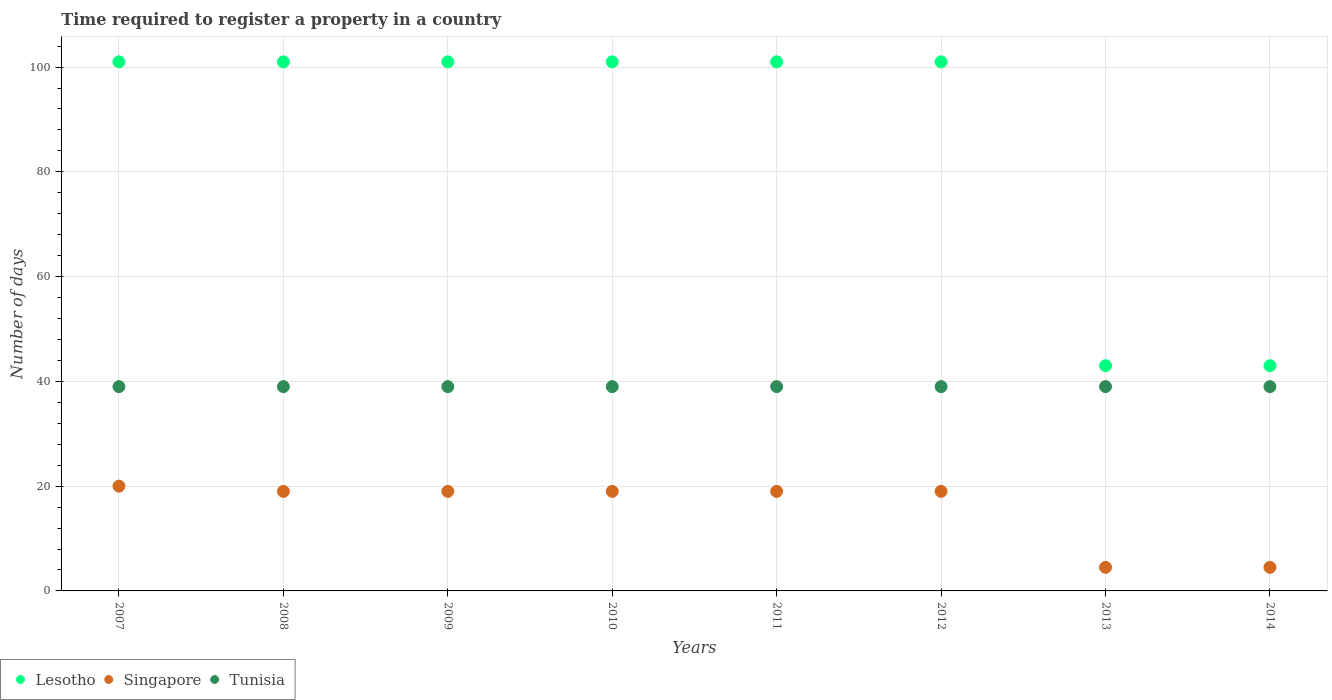Is the number of dotlines equal to the number of legend labels?
Provide a short and direct response. Yes. What is the number of days required to register a property in Tunisia in 2007?
Provide a succinct answer. 39. Across all years, what is the maximum number of days required to register a property in Tunisia?
Your answer should be very brief. 39. Across all years, what is the minimum number of days required to register a property in Lesotho?
Offer a very short reply. 43. What is the total number of days required to register a property in Lesotho in the graph?
Keep it short and to the point. 692. What is the average number of days required to register a property in Lesotho per year?
Provide a short and direct response. 86.5. In the year 2014, what is the difference between the number of days required to register a property in Lesotho and number of days required to register a property in Singapore?
Offer a very short reply. 38.5. What is the ratio of the number of days required to register a property in Singapore in 2011 to that in 2013?
Your answer should be compact. 4.22. Is the difference between the number of days required to register a property in Lesotho in 2010 and 2012 greater than the difference between the number of days required to register a property in Singapore in 2010 and 2012?
Offer a very short reply. No. What is the difference between the highest and the second highest number of days required to register a property in Tunisia?
Keep it short and to the point. 0. What is the difference between the highest and the lowest number of days required to register a property in Lesotho?
Provide a short and direct response. 58. Is the sum of the number of days required to register a property in Tunisia in 2007 and 2014 greater than the maximum number of days required to register a property in Singapore across all years?
Your response must be concise. Yes. Is it the case that in every year, the sum of the number of days required to register a property in Singapore and number of days required to register a property in Tunisia  is greater than the number of days required to register a property in Lesotho?
Your answer should be very brief. No. Does the number of days required to register a property in Lesotho monotonically increase over the years?
Offer a very short reply. No. Is the number of days required to register a property in Singapore strictly greater than the number of days required to register a property in Lesotho over the years?
Your answer should be very brief. No. Is the number of days required to register a property in Tunisia strictly less than the number of days required to register a property in Singapore over the years?
Ensure brevity in your answer.  No. Does the graph contain grids?
Provide a short and direct response. Yes. How many legend labels are there?
Your answer should be compact. 3. How are the legend labels stacked?
Offer a terse response. Horizontal. What is the title of the graph?
Give a very brief answer. Time required to register a property in a country. What is the label or title of the Y-axis?
Offer a very short reply. Number of days. What is the Number of days of Lesotho in 2007?
Keep it short and to the point. 101. What is the Number of days in Tunisia in 2007?
Provide a succinct answer. 39. What is the Number of days in Lesotho in 2008?
Offer a terse response. 101. What is the Number of days of Singapore in 2008?
Your answer should be very brief. 19. What is the Number of days in Tunisia in 2008?
Keep it short and to the point. 39. What is the Number of days of Lesotho in 2009?
Your answer should be compact. 101. What is the Number of days of Singapore in 2009?
Keep it short and to the point. 19. What is the Number of days of Lesotho in 2010?
Offer a very short reply. 101. What is the Number of days in Singapore in 2010?
Give a very brief answer. 19. What is the Number of days of Tunisia in 2010?
Ensure brevity in your answer.  39. What is the Number of days in Lesotho in 2011?
Provide a succinct answer. 101. What is the Number of days of Singapore in 2011?
Provide a short and direct response. 19. What is the Number of days of Lesotho in 2012?
Offer a terse response. 101. What is the Number of days of Singapore in 2012?
Your answer should be compact. 19. What is the Number of days of Tunisia in 2012?
Your answer should be compact. 39. What is the Number of days in Lesotho in 2013?
Provide a succinct answer. 43. What is the Number of days in Singapore in 2013?
Your response must be concise. 4.5. What is the Number of days in Singapore in 2014?
Offer a terse response. 4.5. What is the Number of days of Tunisia in 2014?
Keep it short and to the point. 39. Across all years, what is the maximum Number of days in Lesotho?
Your response must be concise. 101. Across all years, what is the maximum Number of days of Tunisia?
Your answer should be compact. 39. Across all years, what is the minimum Number of days of Singapore?
Provide a short and direct response. 4.5. What is the total Number of days of Lesotho in the graph?
Provide a short and direct response. 692. What is the total Number of days in Singapore in the graph?
Your answer should be compact. 124. What is the total Number of days in Tunisia in the graph?
Ensure brevity in your answer.  312. What is the difference between the Number of days in Singapore in 2007 and that in 2008?
Your answer should be very brief. 1. What is the difference between the Number of days of Tunisia in 2007 and that in 2008?
Offer a terse response. 0. What is the difference between the Number of days of Singapore in 2007 and that in 2009?
Provide a succinct answer. 1. What is the difference between the Number of days in Tunisia in 2007 and that in 2009?
Keep it short and to the point. 0. What is the difference between the Number of days of Lesotho in 2007 and that in 2010?
Ensure brevity in your answer.  0. What is the difference between the Number of days of Tunisia in 2007 and that in 2010?
Provide a succinct answer. 0. What is the difference between the Number of days in Lesotho in 2007 and that in 2011?
Make the answer very short. 0. What is the difference between the Number of days of Lesotho in 2007 and that in 2012?
Provide a succinct answer. 0. What is the difference between the Number of days in Tunisia in 2007 and that in 2012?
Provide a short and direct response. 0. What is the difference between the Number of days in Singapore in 2007 and that in 2013?
Give a very brief answer. 15.5. What is the difference between the Number of days of Tunisia in 2007 and that in 2013?
Give a very brief answer. 0. What is the difference between the Number of days of Lesotho in 2007 and that in 2014?
Make the answer very short. 58. What is the difference between the Number of days in Tunisia in 2007 and that in 2014?
Give a very brief answer. 0. What is the difference between the Number of days of Lesotho in 2008 and that in 2009?
Your response must be concise. 0. What is the difference between the Number of days in Singapore in 2008 and that in 2009?
Keep it short and to the point. 0. What is the difference between the Number of days in Singapore in 2008 and that in 2011?
Offer a terse response. 0. What is the difference between the Number of days in Tunisia in 2008 and that in 2011?
Offer a very short reply. 0. What is the difference between the Number of days in Lesotho in 2008 and that in 2012?
Provide a short and direct response. 0. What is the difference between the Number of days in Singapore in 2008 and that in 2012?
Give a very brief answer. 0. What is the difference between the Number of days in Tunisia in 2008 and that in 2012?
Make the answer very short. 0. What is the difference between the Number of days of Lesotho in 2008 and that in 2013?
Offer a terse response. 58. What is the difference between the Number of days of Singapore in 2008 and that in 2013?
Provide a succinct answer. 14.5. What is the difference between the Number of days of Tunisia in 2008 and that in 2013?
Your answer should be compact. 0. What is the difference between the Number of days in Tunisia in 2008 and that in 2014?
Offer a terse response. 0. What is the difference between the Number of days in Lesotho in 2009 and that in 2010?
Ensure brevity in your answer.  0. What is the difference between the Number of days in Lesotho in 2009 and that in 2011?
Ensure brevity in your answer.  0. What is the difference between the Number of days in Singapore in 2009 and that in 2011?
Ensure brevity in your answer.  0. What is the difference between the Number of days of Lesotho in 2009 and that in 2012?
Keep it short and to the point. 0. What is the difference between the Number of days of Tunisia in 2009 and that in 2013?
Ensure brevity in your answer.  0. What is the difference between the Number of days of Singapore in 2009 and that in 2014?
Make the answer very short. 14.5. What is the difference between the Number of days of Tunisia in 2010 and that in 2011?
Your answer should be compact. 0. What is the difference between the Number of days of Lesotho in 2010 and that in 2013?
Offer a terse response. 58. What is the difference between the Number of days in Lesotho in 2010 and that in 2014?
Your answer should be very brief. 58. What is the difference between the Number of days in Singapore in 2010 and that in 2014?
Provide a succinct answer. 14.5. What is the difference between the Number of days in Tunisia in 2011 and that in 2012?
Your answer should be compact. 0. What is the difference between the Number of days in Tunisia in 2011 and that in 2013?
Offer a very short reply. 0. What is the difference between the Number of days in Tunisia in 2011 and that in 2014?
Make the answer very short. 0. What is the difference between the Number of days of Singapore in 2012 and that in 2013?
Ensure brevity in your answer.  14.5. What is the difference between the Number of days in Lesotho in 2012 and that in 2014?
Provide a succinct answer. 58. What is the difference between the Number of days of Lesotho in 2013 and that in 2014?
Make the answer very short. 0. What is the difference between the Number of days in Singapore in 2013 and that in 2014?
Make the answer very short. 0. What is the difference between the Number of days of Tunisia in 2013 and that in 2014?
Ensure brevity in your answer.  0. What is the difference between the Number of days in Lesotho in 2007 and the Number of days in Tunisia in 2008?
Provide a succinct answer. 62. What is the difference between the Number of days of Singapore in 2007 and the Number of days of Tunisia in 2008?
Offer a terse response. -19. What is the difference between the Number of days of Singapore in 2007 and the Number of days of Tunisia in 2009?
Your answer should be very brief. -19. What is the difference between the Number of days in Lesotho in 2007 and the Number of days in Singapore in 2010?
Ensure brevity in your answer.  82. What is the difference between the Number of days in Lesotho in 2007 and the Number of days in Tunisia in 2010?
Offer a very short reply. 62. What is the difference between the Number of days of Lesotho in 2007 and the Number of days of Singapore in 2011?
Provide a short and direct response. 82. What is the difference between the Number of days in Lesotho in 2007 and the Number of days in Singapore in 2012?
Your answer should be compact. 82. What is the difference between the Number of days in Lesotho in 2007 and the Number of days in Singapore in 2013?
Make the answer very short. 96.5. What is the difference between the Number of days in Singapore in 2007 and the Number of days in Tunisia in 2013?
Ensure brevity in your answer.  -19. What is the difference between the Number of days in Lesotho in 2007 and the Number of days in Singapore in 2014?
Your response must be concise. 96.5. What is the difference between the Number of days in Singapore in 2007 and the Number of days in Tunisia in 2014?
Offer a very short reply. -19. What is the difference between the Number of days of Singapore in 2008 and the Number of days of Tunisia in 2009?
Offer a terse response. -20. What is the difference between the Number of days in Lesotho in 2008 and the Number of days in Singapore in 2010?
Ensure brevity in your answer.  82. What is the difference between the Number of days in Singapore in 2008 and the Number of days in Tunisia in 2010?
Make the answer very short. -20. What is the difference between the Number of days in Lesotho in 2008 and the Number of days in Singapore in 2011?
Your answer should be compact. 82. What is the difference between the Number of days of Lesotho in 2008 and the Number of days of Tunisia in 2012?
Provide a short and direct response. 62. What is the difference between the Number of days in Lesotho in 2008 and the Number of days in Singapore in 2013?
Your answer should be very brief. 96.5. What is the difference between the Number of days in Lesotho in 2008 and the Number of days in Tunisia in 2013?
Ensure brevity in your answer.  62. What is the difference between the Number of days of Singapore in 2008 and the Number of days of Tunisia in 2013?
Your answer should be very brief. -20. What is the difference between the Number of days of Lesotho in 2008 and the Number of days of Singapore in 2014?
Give a very brief answer. 96.5. What is the difference between the Number of days of Singapore in 2008 and the Number of days of Tunisia in 2014?
Provide a short and direct response. -20. What is the difference between the Number of days of Lesotho in 2009 and the Number of days of Singapore in 2010?
Offer a terse response. 82. What is the difference between the Number of days of Lesotho in 2009 and the Number of days of Tunisia in 2010?
Your answer should be compact. 62. What is the difference between the Number of days in Singapore in 2009 and the Number of days in Tunisia in 2010?
Your response must be concise. -20. What is the difference between the Number of days in Lesotho in 2009 and the Number of days in Singapore in 2011?
Your answer should be compact. 82. What is the difference between the Number of days of Lesotho in 2009 and the Number of days of Singapore in 2012?
Provide a succinct answer. 82. What is the difference between the Number of days of Lesotho in 2009 and the Number of days of Tunisia in 2012?
Your answer should be very brief. 62. What is the difference between the Number of days of Lesotho in 2009 and the Number of days of Singapore in 2013?
Provide a short and direct response. 96.5. What is the difference between the Number of days of Lesotho in 2009 and the Number of days of Singapore in 2014?
Give a very brief answer. 96.5. What is the difference between the Number of days in Singapore in 2009 and the Number of days in Tunisia in 2014?
Keep it short and to the point. -20. What is the difference between the Number of days in Lesotho in 2010 and the Number of days in Singapore in 2011?
Your answer should be compact. 82. What is the difference between the Number of days in Singapore in 2010 and the Number of days in Tunisia in 2011?
Your answer should be compact. -20. What is the difference between the Number of days in Lesotho in 2010 and the Number of days in Singapore in 2012?
Provide a succinct answer. 82. What is the difference between the Number of days in Singapore in 2010 and the Number of days in Tunisia in 2012?
Your response must be concise. -20. What is the difference between the Number of days of Lesotho in 2010 and the Number of days of Singapore in 2013?
Your answer should be very brief. 96.5. What is the difference between the Number of days of Lesotho in 2010 and the Number of days of Tunisia in 2013?
Provide a succinct answer. 62. What is the difference between the Number of days in Singapore in 2010 and the Number of days in Tunisia in 2013?
Your response must be concise. -20. What is the difference between the Number of days in Lesotho in 2010 and the Number of days in Singapore in 2014?
Your answer should be compact. 96.5. What is the difference between the Number of days in Lesotho in 2010 and the Number of days in Tunisia in 2014?
Your response must be concise. 62. What is the difference between the Number of days in Lesotho in 2011 and the Number of days in Singapore in 2012?
Ensure brevity in your answer.  82. What is the difference between the Number of days in Lesotho in 2011 and the Number of days in Singapore in 2013?
Ensure brevity in your answer.  96.5. What is the difference between the Number of days of Lesotho in 2011 and the Number of days of Tunisia in 2013?
Make the answer very short. 62. What is the difference between the Number of days in Lesotho in 2011 and the Number of days in Singapore in 2014?
Your answer should be very brief. 96.5. What is the difference between the Number of days in Lesotho in 2011 and the Number of days in Tunisia in 2014?
Keep it short and to the point. 62. What is the difference between the Number of days in Singapore in 2011 and the Number of days in Tunisia in 2014?
Offer a terse response. -20. What is the difference between the Number of days of Lesotho in 2012 and the Number of days of Singapore in 2013?
Give a very brief answer. 96.5. What is the difference between the Number of days of Lesotho in 2012 and the Number of days of Singapore in 2014?
Make the answer very short. 96.5. What is the difference between the Number of days in Lesotho in 2012 and the Number of days in Tunisia in 2014?
Offer a terse response. 62. What is the difference between the Number of days in Lesotho in 2013 and the Number of days in Singapore in 2014?
Your answer should be very brief. 38.5. What is the difference between the Number of days in Lesotho in 2013 and the Number of days in Tunisia in 2014?
Ensure brevity in your answer.  4. What is the difference between the Number of days of Singapore in 2013 and the Number of days of Tunisia in 2014?
Keep it short and to the point. -34.5. What is the average Number of days of Lesotho per year?
Offer a very short reply. 86.5. What is the average Number of days of Tunisia per year?
Offer a very short reply. 39. In the year 2007, what is the difference between the Number of days of Lesotho and Number of days of Singapore?
Your answer should be very brief. 81. In the year 2008, what is the difference between the Number of days of Singapore and Number of days of Tunisia?
Offer a terse response. -20. In the year 2010, what is the difference between the Number of days of Lesotho and Number of days of Singapore?
Provide a short and direct response. 82. In the year 2010, what is the difference between the Number of days of Lesotho and Number of days of Tunisia?
Offer a very short reply. 62. In the year 2010, what is the difference between the Number of days in Singapore and Number of days in Tunisia?
Provide a succinct answer. -20. In the year 2011, what is the difference between the Number of days in Lesotho and Number of days in Tunisia?
Give a very brief answer. 62. In the year 2012, what is the difference between the Number of days of Lesotho and Number of days of Singapore?
Make the answer very short. 82. In the year 2012, what is the difference between the Number of days of Lesotho and Number of days of Tunisia?
Your answer should be compact. 62. In the year 2013, what is the difference between the Number of days in Lesotho and Number of days in Singapore?
Offer a very short reply. 38.5. In the year 2013, what is the difference between the Number of days of Singapore and Number of days of Tunisia?
Provide a succinct answer. -34.5. In the year 2014, what is the difference between the Number of days of Lesotho and Number of days of Singapore?
Give a very brief answer. 38.5. In the year 2014, what is the difference between the Number of days of Singapore and Number of days of Tunisia?
Your answer should be very brief. -34.5. What is the ratio of the Number of days of Singapore in 2007 to that in 2008?
Your answer should be compact. 1.05. What is the ratio of the Number of days in Singapore in 2007 to that in 2009?
Your answer should be very brief. 1.05. What is the ratio of the Number of days in Singapore in 2007 to that in 2010?
Your response must be concise. 1.05. What is the ratio of the Number of days of Singapore in 2007 to that in 2011?
Offer a very short reply. 1.05. What is the ratio of the Number of days in Singapore in 2007 to that in 2012?
Your response must be concise. 1.05. What is the ratio of the Number of days of Lesotho in 2007 to that in 2013?
Ensure brevity in your answer.  2.35. What is the ratio of the Number of days in Singapore in 2007 to that in 2013?
Give a very brief answer. 4.44. What is the ratio of the Number of days of Tunisia in 2007 to that in 2013?
Ensure brevity in your answer.  1. What is the ratio of the Number of days in Lesotho in 2007 to that in 2014?
Ensure brevity in your answer.  2.35. What is the ratio of the Number of days in Singapore in 2007 to that in 2014?
Make the answer very short. 4.44. What is the ratio of the Number of days in Lesotho in 2008 to that in 2010?
Make the answer very short. 1. What is the ratio of the Number of days of Tunisia in 2008 to that in 2010?
Offer a very short reply. 1. What is the ratio of the Number of days of Singapore in 2008 to that in 2012?
Give a very brief answer. 1. What is the ratio of the Number of days in Lesotho in 2008 to that in 2013?
Give a very brief answer. 2.35. What is the ratio of the Number of days in Singapore in 2008 to that in 2013?
Ensure brevity in your answer.  4.22. What is the ratio of the Number of days of Lesotho in 2008 to that in 2014?
Give a very brief answer. 2.35. What is the ratio of the Number of days of Singapore in 2008 to that in 2014?
Your response must be concise. 4.22. What is the ratio of the Number of days of Tunisia in 2008 to that in 2014?
Offer a terse response. 1. What is the ratio of the Number of days of Lesotho in 2009 to that in 2010?
Give a very brief answer. 1. What is the ratio of the Number of days in Singapore in 2009 to that in 2010?
Keep it short and to the point. 1. What is the ratio of the Number of days in Tunisia in 2009 to that in 2010?
Your answer should be very brief. 1. What is the ratio of the Number of days of Lesotho in 2009 to that in 2011?
Make the answer very short. 1. What is the ratio of the Number of days of Singapore in 2009 to that in 2011?
Your response must be concise. 1. What is the ratio of the Number of days in Tunisia in 2009 to that in 2011?
Provide a short and direct response. 1. What is the ratio of the Number of days of Singapore in 2009 to that in 2012?
Your answer should be very brief. 1. What is the ratio of the Number of days of Lesotho in 2009 to that in 2013?
Make the answer very short. 2.35. What is the ratio of the Number of days of Singapore in 2009 to that in 2013?
Provide a short and direct response. 4.22. What is the ratio of the Number of days in Tunisia in 2009 to that in 2013?
Give a very brief answer. 1. What is the ratio of the Number of days of Lesotho in 2009 to that in 2014?
Provide a succinct answer. 2.35. What is the ratio of the Number of days in Singapore in 2009 to that in 2014?
Offer a very short reply. 4.22. What is the ratio of the Number of days in Lesotho in 2010 to that in 2011?
Give a very brief answer. 1. What is the ratio of the Number of days in Singapore in 2010 to that in 2011?
Ensure brevity in your answer.  1. What is the ratio of the Number of days in Lesotho in 2010 to that in 2012?
Your answer should be very brief. 1. What is the ratio of the Number of days of Lesotho in 2010 to that in 2013?
Offer a very short reply. 2.35. What is the ratio of the Number of days of Singapore in 2010 to that in 2013?
Your response must be concise. 4.22. What is the ratio of the Number of days in Tunisia in 2010 to that in 2013?
Your response must be concise. 1. What is the ratio of the Number of days in Lesotho in 2010 to that in 2014?
Make the answer very short. 2.35. What is the ratio of the Number of days of Singapore in 2010 to that in 2014?
Your response must be concise. 4.22. What is the ratio of the Number of days of Singapore in 2011 to that in 2012?
Offer a very short reply. 1. What is the ratio of the Number of days in Lesotho in 2011 to that in 2013?
Your answer should be very brief. 2.35. What is the ratio of the Number of days of Singapore in 2011 to that in 2013?
Make the answer very short. 4.22. What is the ratio of the Number of days of Tunisia in 2011 to that in 2013?
Your answer should be very brief. 1. What is the ratio of the Number of days in Lesotho in 2011 to that in 2014?
Your answer should be very brief. 2.35. What is the ratio of the Number of days in Singapore in 2011 to that in 2014?
Keep it short and to the point. 4.22. What is the ratio of the Number of days of Lesotho in 2012 to that in 2013?
Your answer should be very brief. 2.35. What is the ratio of the Number of days of Singapore in 2012 to that in 2013?
Provide a succinct answer. 4.22. What is the ratio of the Number of days in Tunisia in 2012 to that in 2013?
Provide a succinct answer. 1. What is the ratio of the Number of days of Lesotho in 2012 to that in 2014?
Offer a terse response. 2.35. What is the ratio of the Number of days of Singapore in 2012 to that in 2014?
Keep it short and to the point. 4.22. What is the ratio of the Number of days in Tunisia in 2012 to that in 2014?
Provide a succinct answer. 1. What is the ratio of the Number of days of Lesotho in 2013 to that in 2014?
Your answer should be compact. 1. What is the ratio of the Number of days of Singapore in 2013 to that in 2014?
Your answer should be compact. 1. What is the ratio of the Number of days of Tunisia in 2013 to that in 2014?
Offer a very short reply. 1. What is the difference between the highest and the second highest Number of days in Tunisia?
Your answer should be compact. 0. What is the difference between the highest and the lowest Number of days of Tunisia?
Keep it short and to the point. 0. 